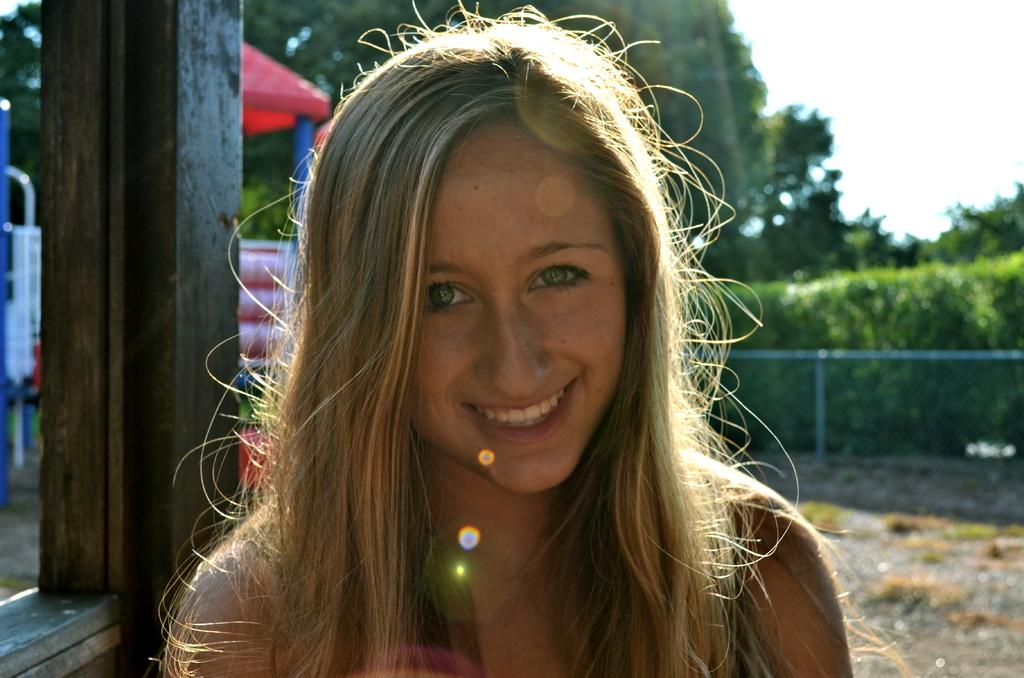Who is present in the image? There is a woman in the image. What is the woman's facial expression? The woman is smiling. What can be seen in the background of the image? There is a red color tint, plants, fencing, trees, and the sky visible in the background. Can you see any ants crawling on the woman's face in the image? There are no ants visible in the image, and they are not crawling on the woman's face. 